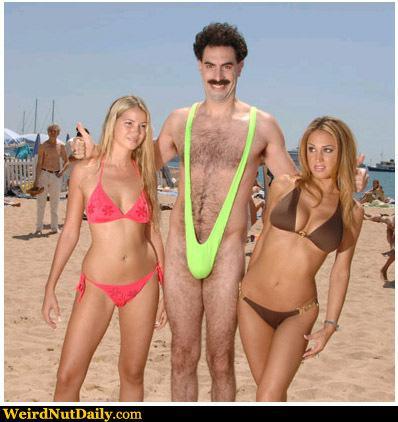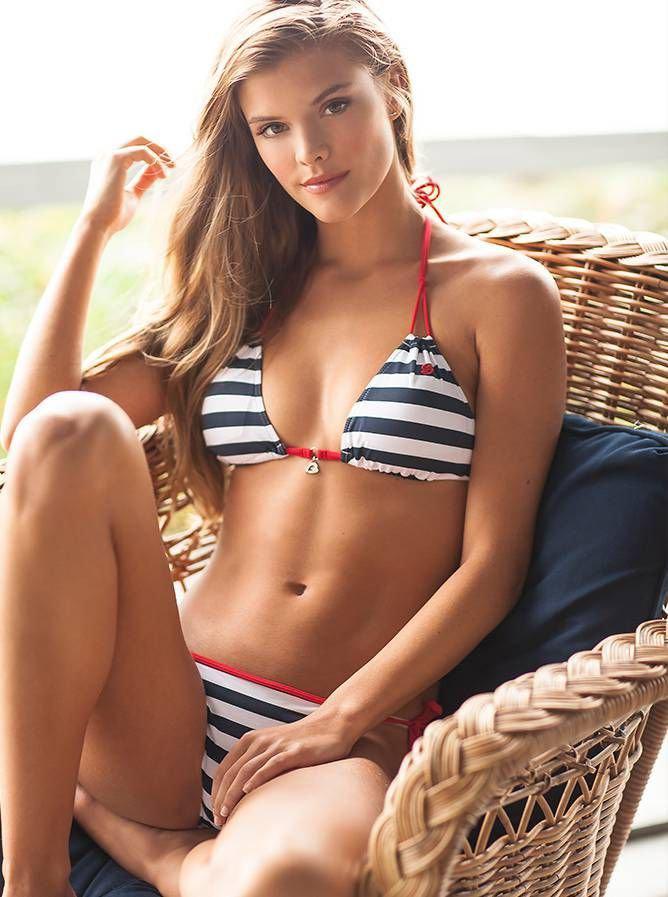The first image is the image on the left, the second image is the image on the right. Evaluate the accuracy of this statement regarding the images: "In the left image, a woman poses in a bikini on a sandy beach by herself". Is it true? Answer yes or no. No. The first image is the image on the left, the second image is the image on the right. Given the left and right images, does the statement "A striped bikini top is modeled in one image." hold true? Answer yes or no. Yes. 